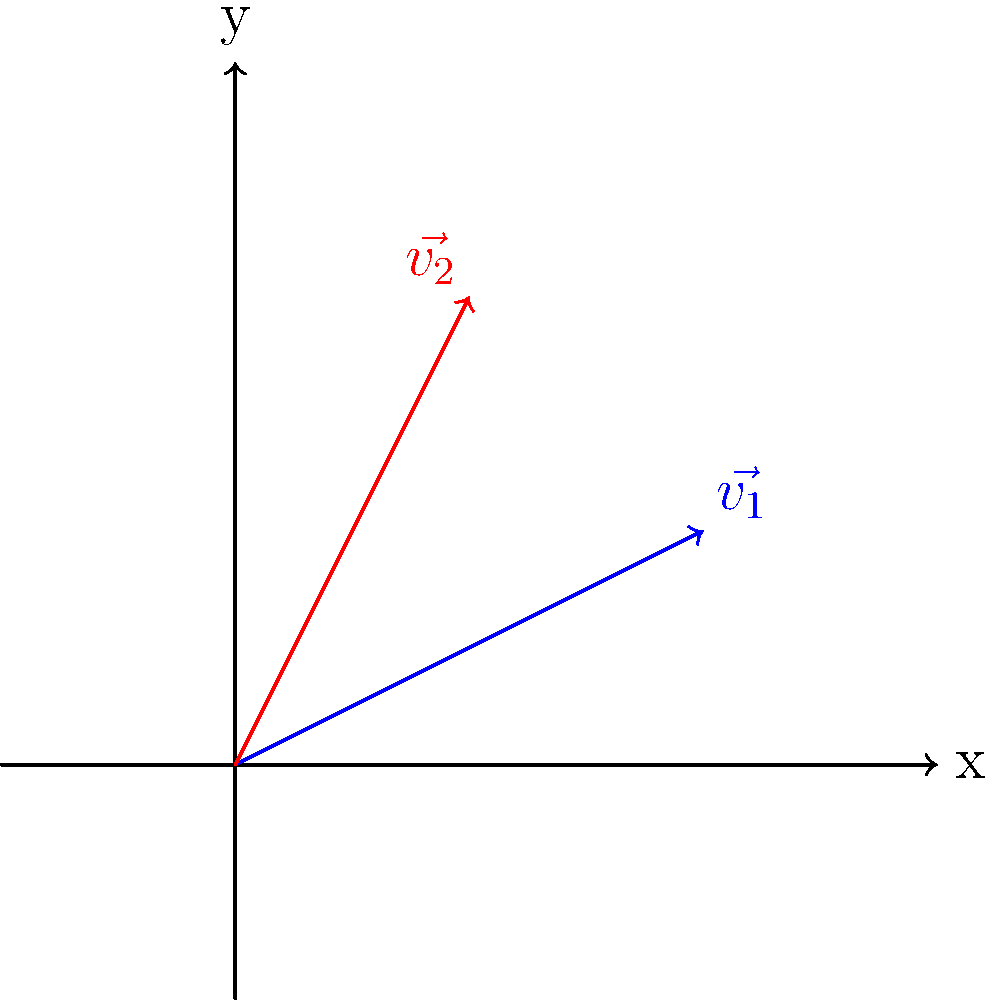In a digital layout, text flow can be represented as vectors. Given two vectors $\vec{v_1} = (2,1)$ and $\vec{v_2} = (1,2)$ representing different text flow directions, calculate the dot product of these vectors. What does this result indicate about the relationship between these text flow directions? To solve this problem, we'll follow these steps:

1. Recall the formula for dot product of two vectors:
   $\vec{a} \cdot \vec{b} = a_x b_x + a_y b_y$

2. Identify the components of each vector:
   $\vec{v_1} = (2,1)$, so $v_{1x} = 2$ and $v_{1y} = 1$
   $\vec{v_2} = (1,2)$, so $v_{2x} = 1$ and $v_{2y} = 2$

3. Apply the dot product formula:
   $\vec{v_1} \cdot \vec{v_2} = (2 \times 1) + (1 \times 2)$

4. Calculate:
   $\vec{v_1} \cdot \vec{v_2} = 2 + 2 = 4$

5. Interpret the result:
   - A positive dot product indicates that the vectors are pointing in generally the same direction.
   - The magnitude of the dot product (4 in this case) suggests a moderate alignment between the vectors.
   - In the context of text flow, this implies that the two text flow directions are somewhat similar but not perfectly aligned.
Answer: 4; moderate alignment of text flow directions 